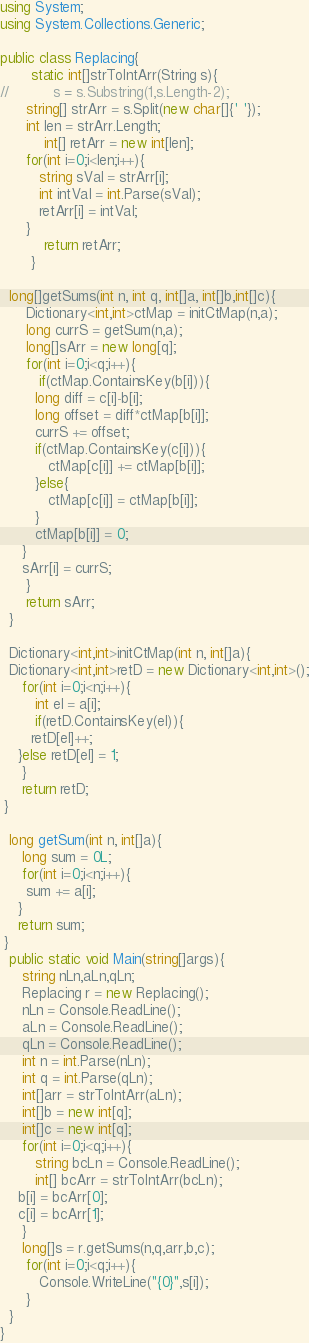Convert code to text. <code><loc_0><loc_0><loc_500><loc_500><_C#_>using System;
using System.Collections.Generic;

public class Replacing{
       static int[]strToIntArr(String s){
//          s = s.Substring(1,s.Length-2);
	  string[] strArr = s.Split(new char[]{' '});
	  int len = strArr.Length;
          int[] retArr = new int[len];       
	  for(int i=0;i<len;i++){
	     string sVal = strArr[i];
	     int intVal = int.Parse(sVal);
	     retArr[i] = intVal;
	  }
          return retArr;
       }

  long[]getSums(int n, int q, int[]a, int[]b,int[]c){
      Dictionary<int,int>ctMap = initCtMap(n,a);
      long currS = getSum(n,a);
      long[]sArr = new long[q];
      for(int i=0;i<q;i++){
         if(ctMap.ContainsKey(b[i])){
	    long diff = c[i]-b[i];
	    long offset = diff*ctMap[b[i]];
	    currS += offset;
	    if(ctMap.ContainsKey(c[i])){
	       ctMap[c[i]] += ctMap[b[i]];
	    }else{
	       ctMap[c[i]] = ctMap[b[i]];	       
	    }
	    ctMap[b[i]] = 0;	    
	 }
	 sArr[i] = currS;
      }
      return sArr;
  }

  Dictionary<int,int>initCtMap(int n, int[]a){
  Dictionary<int,int>retD = new Dictionary<int,int>();
     for(int i=0;i<n;i++){
        int el = a[i];
        if(retD.ContainsKey(el)){
	   retD[el]++;
	}else retD[el] = 1;
     }
     return retD;
 }

  long getSum(int n, int[]a){
     long sum = 0L;
     for(int i=0;i<n;i++){
      sum += a[i];
    }
    return sum;
 }
  public static void Main(string[]args){
     string nLn,aLn,qLn;
     Replacing r = new Replacing();
     nLn = Console.ReadLine();
     aLn = Console.ReadLine();
     qLn = Console.ReadLine();
     int n = int.Parse(nLn);
     int q = int.Parse(qLn);
     int[]arr = strToIntArr(aLn);
     int[]b = new int[q];
     int[]c = new int[q];
     for(int i=0;i<q;i++){
        string bcLn = Console.ReadLine();
        int[] bcArr = strToIntArr(bcLn);
	b[i] = bcArr[0];
	c[i] = bcArr[1];
     }
     long[]s = r.getSums(n,q,arr,b,c);
      for(int i=0;i<q;i++){
         Console.WriteLine("{0}",s[i]);
      }
  }
}</code> 